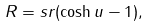Convert formula to latex. <formula><loc_0><loc_0><loc_500><loc_500>R = s r ( \cosh u - 1 ) ,</formula> 